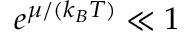<formula> <loc_0><loc_0><loc_500><loc_500>e ^ { \mu / ( k _ { B } T ) } \ll 1</formula> 